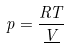Convert formula to latex. <formula><loc_0><loc_0><loc_500><loc_500>p = \frac { R T } { \underline { V } }</formula> 